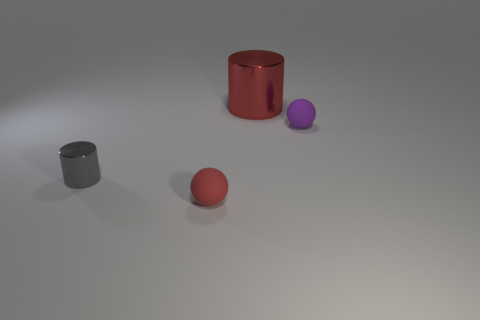Are there any big green shiny things?
Make the answer very short. No. Is the tiny purple sphere that is behind the gray object made of the same material as the big red cylinder?
Your answer should be compact. No. The sphere that is the same color as the big shiny thing is what size?
Keep it short and to the point. Small. How many gray shiny things are the same size as the purple object?
Provide a short and direct response. 1. Are there the same number of tiny red spheres in front of the tiny purple object and small gray shiny things?
Your response must be concise. Yes. What number of objects are both left of the tiny purple matte object and on the right side of the tiny red object?
Keep it short and to the point. 1. The purple object that is the same material as the small red ball is what size?
Your answer should be compact. Small. What number of other small objects have the same shape as the small red thing?
Give a very brief answer. 1. Are there more small gray things to the left of the small gray shiny object than small metal cylinders?
Offer a very short reply. No. What is the shape of the thing that is in front of the purple rubber sphere and behind the tiny red object?
Your answer should be very brief. Cylinder. 